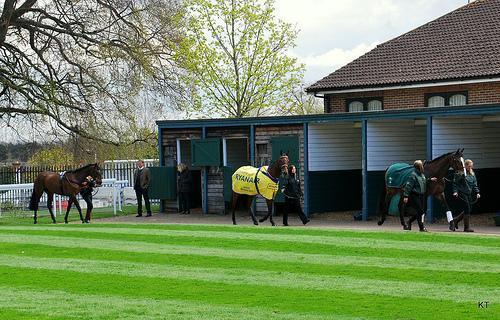How many people are shown?
Give a very brief answer. 6. How many white horses are there?
Give a very brief answer. 0. 